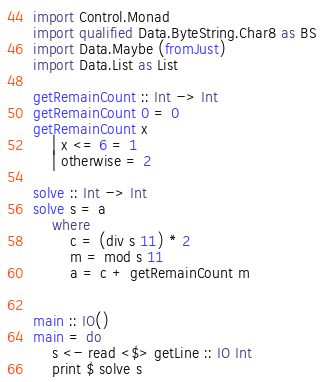<code> <loc_0><loc_0><loc_500><loc_500><_Haskell_>import Control.Monad
import qualified Data.ByteString.Char8 as BS
import Data.Maybe (fromJust)
import Data.List as List

getRemainCount :: Int -> Int
getRemainCount 0 = 0
getRemainCount x
    | x <= 6 = 1
    | otherwise = 2

solve :: Int -> Int
solve s = a
    where
        c = (div s 11) * 2
        m = mod s 11
        a = c + getRemainCount m    


main :: IO()
main = do
    s <- read <$> getLine :: IO Int
    print $ solve s
</code> 